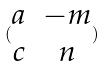<formula> <loc_0><loc_0><loc_500><loc_500>( \begin{matrix} a & - m \\ c & n \end{matrix} )</formula> 